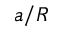<formula> <loc_0><loc_0><loc_500><loc_500>a / R</formula> 